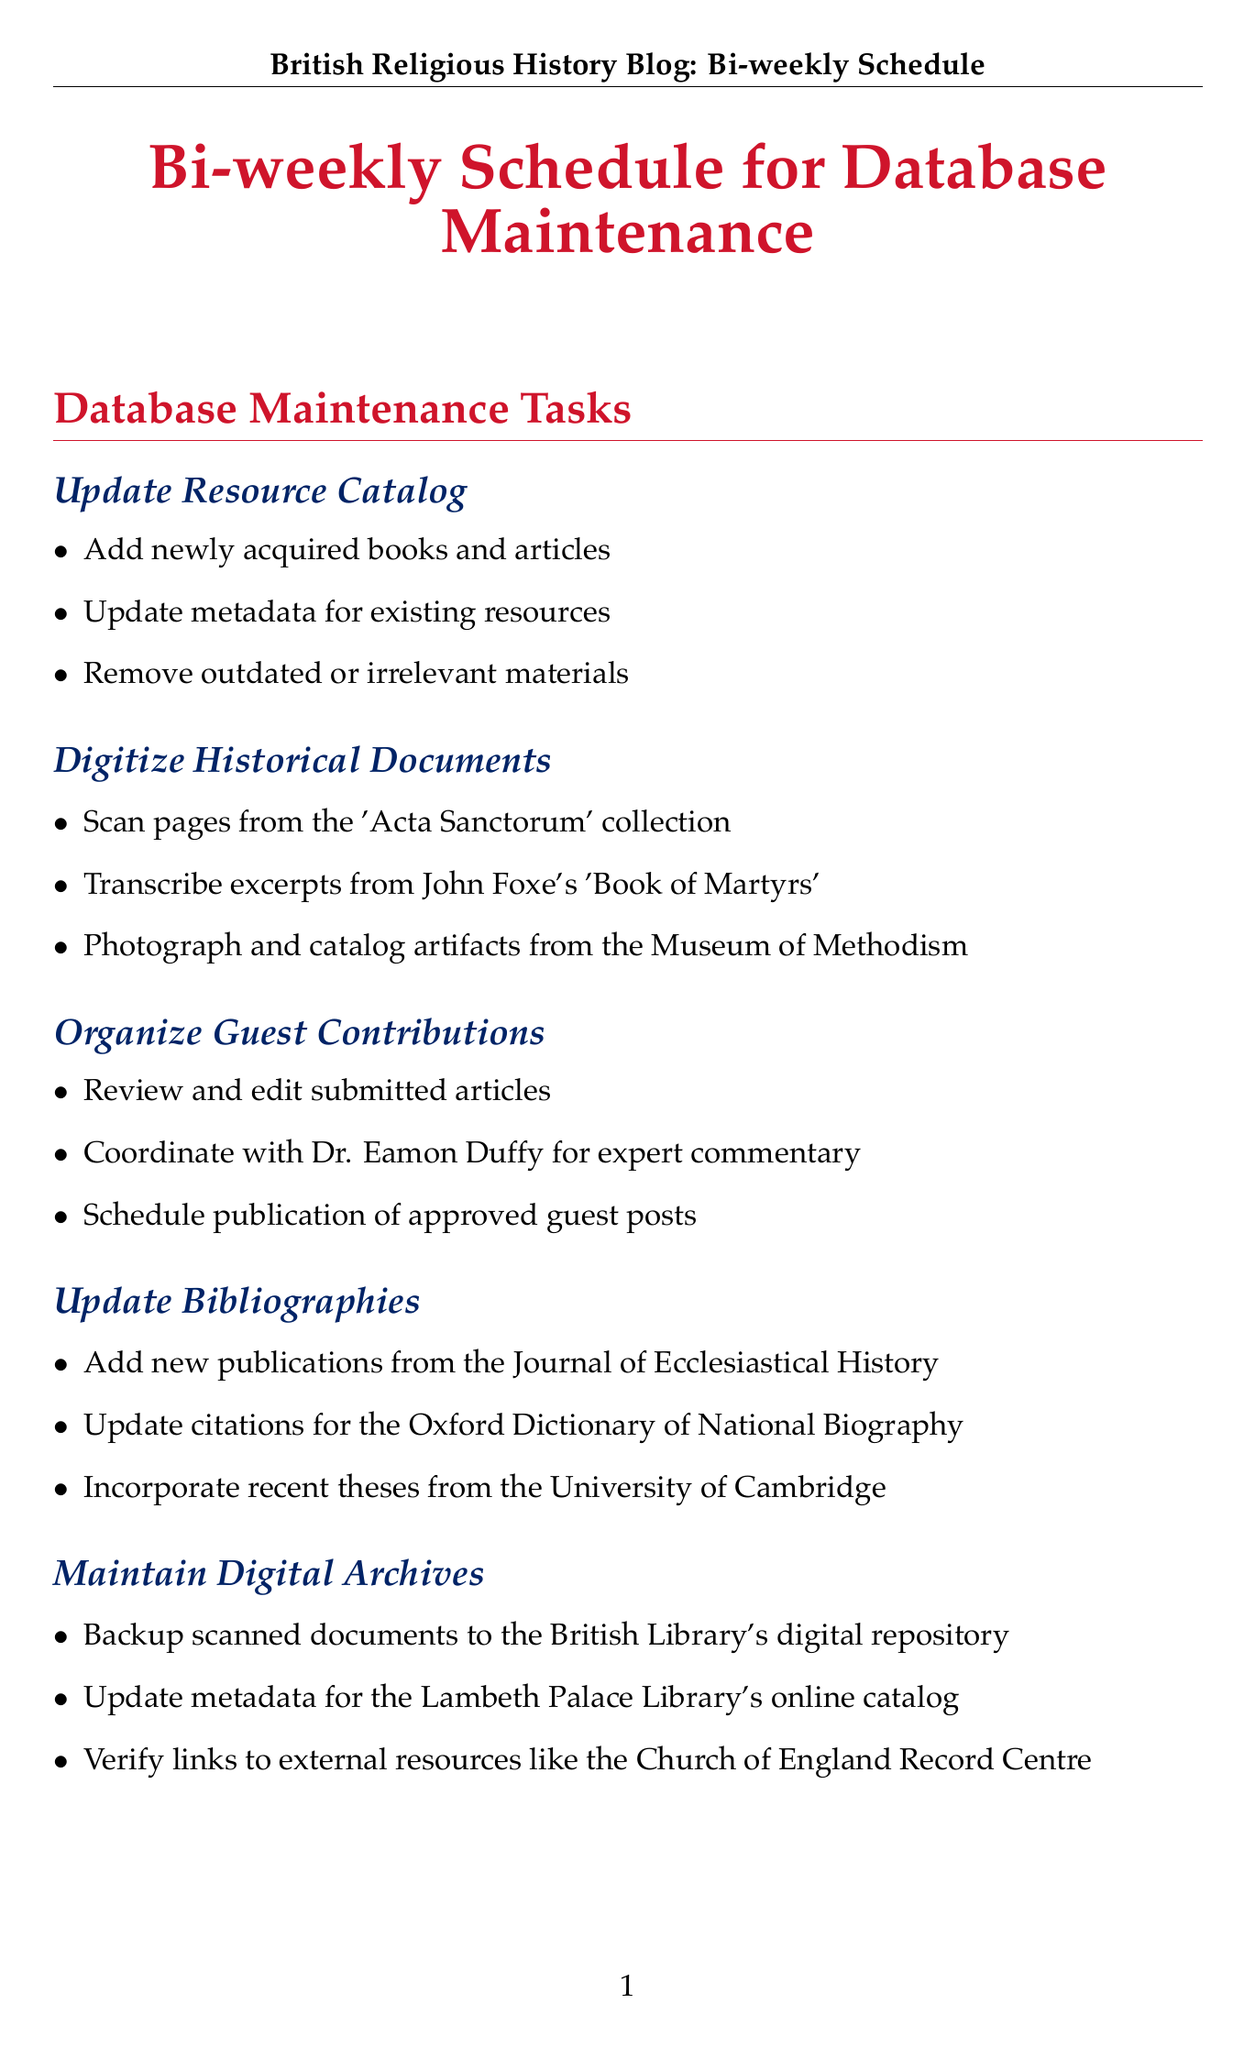What is the frequency of updating the resource catalog? The document states that the updating of the resource catalog is scheduled to occur bi-weekly.
Answer: Bi-weekly Which document collection will be scanned for digitization? The task specifies scanning pages from the 'Acta Sanctorum' collection for digitization.
Answer: Acta Sanctorum Who is mentioned for coordinating expert commentary? The document lists Dr. Eamon Duffy as the person to coordinate for expert commentary on guest contributions.
Answer: Dr. Eamon Duffy How many tasks are listed under database maintenance tasks? The document outlines a total of eight tasks under the database maintenance section.
Answer: Eight What is one of the subtasks under maintaining digital archives? The document includes backing up scanned documents to the British Library's digital repository as a subtask under maintaining digital archives.
Answer: Backup scanned documents What type of community engagement is mentioned in the schedule? One way to engage with the community as identified in the document is to organize virtual meetups with the British Association for Local History.
Answer: Organize virtual meetups What is one of the new publications to be added to the bibliographies? The document states that new publications from the Journal of Ecclesiastical History will be incorporated into the bibliographies.
Answer: Journal of Ecclesiastical History Which academic institution is mentioned for collaboration? The document includes coordinating with the University of Oxford's Faculty of Theology and Religion for collaboration.
Answer: University of Oxford 